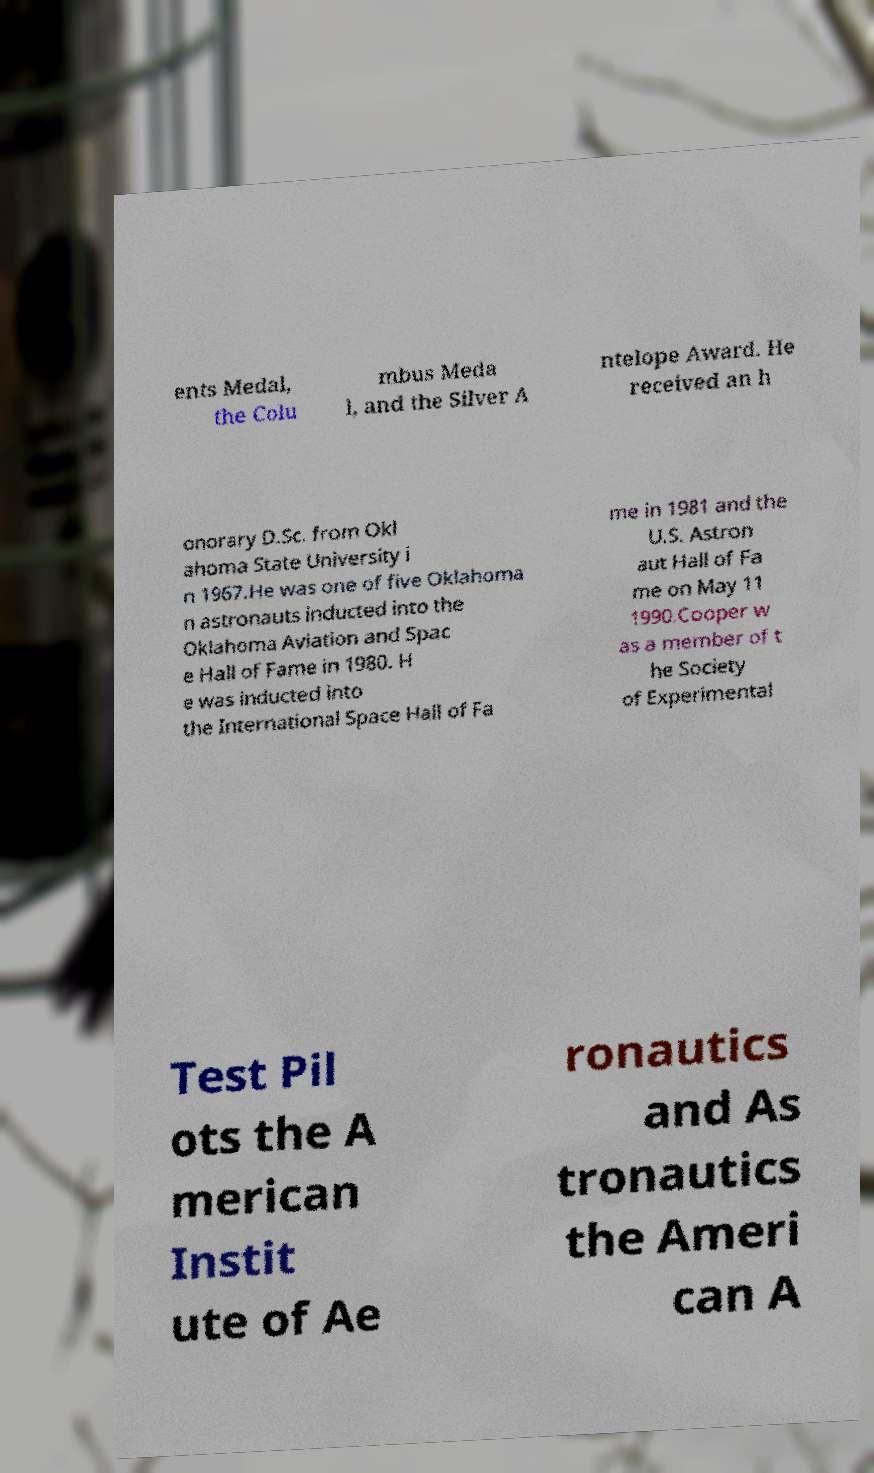Can you read and provide the text displayed in the image?This photo seems to have some interesting text. Can you extract and type it out for me? ents Medal, the Colu mbus Meda l, and the Silver A ntelope Award. He received an h onorary D.Sc. from Okl ahoma State University i n 1967.He was one of five Oklahoma n astronauts inducted into the Oklahoma Aviation and Spac e Hall of Fame in 1980. H e was inducted into the International Space Hall of Fa me in 1981 and the U.S. Astron aut Hall of Fa me on May 11 1990.Cooper w as a member of t he Society of Experimental Test Pil ots the A merican Instit ute of Ae ronautics and As tronautics the Ameri can A 